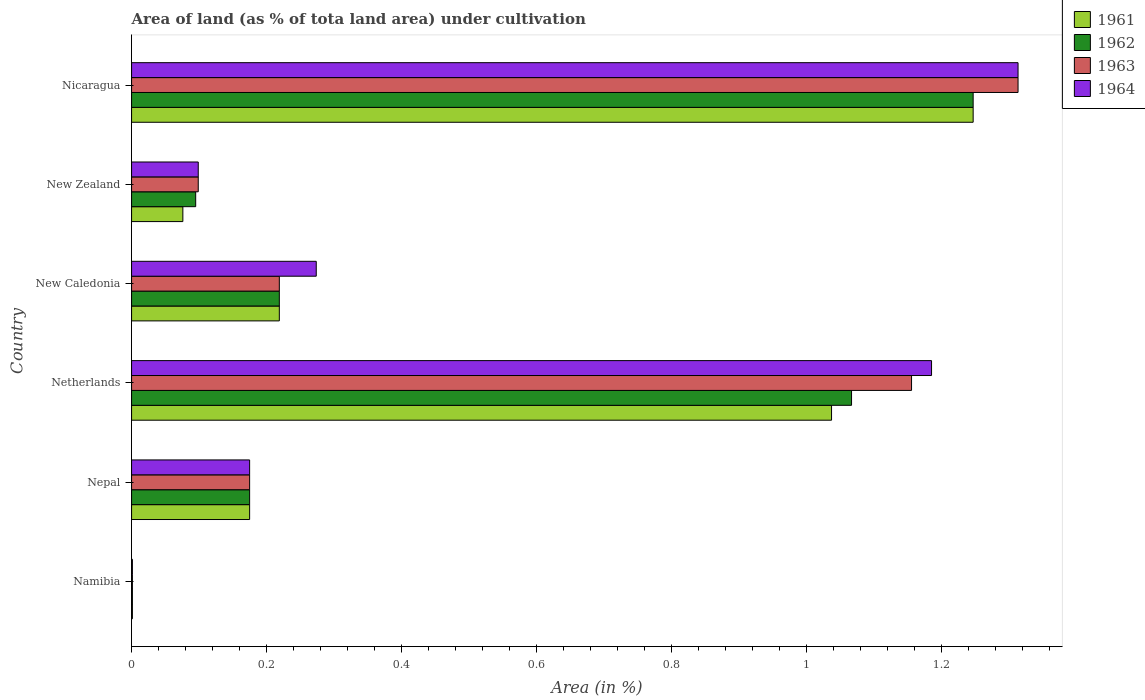How many different coloured bars are there?
Give a very brief answer. 4. Are the number of bars per tick equal to the number of legend labels?
Provide a succinct answer. Yes. Are the number of bars on each tick of the Y-axis equal?
Your answer should be compact. Yes. How many bars are there on the 6th tick from the top?
Offer a terse response. 4. What is the label of the 2nd group of bars from the top?
Offer a very short reply. New Zealand. What is the percentage of land under cultivation in 1961 in New Zealand?
Provide a short and direct response. 0.08. Across all countries, what is the maximum percentage of land under cultivation in 1962?
Provide a short and direct response. 1.25. Across all countries, what is the minimum percentage of land under cultivation in 1962?
Provide a succinct answer. 0. In which country was the percentage of land under cultivation in 1961 maximum?
Ensure brevity in your answer.  Nicaragua. In which country was the percentage of land under cultivation in 1961 minimum?
Your answer should be very brief. Namibia. What is the total percentage of land under cultivation in 1964 in the graph?
Ensure brevity in your answer.  3.05. What is the difference between the percentage of land under cultivation in 1964 in Nepal and that in New Zealand?
Provide a short and direct response. 0.08. What is the difference between the percentage of land under cultivation in 1963 in Nicaragua and the percentage of land under cultivation in 1961 in New Caledonia?
Your answer should be compact. 1.09. What is the average percentage of land under cultivation in 1961 per country?
Offer a very short reply. 0.46. What is the difference between the percentage of land under cultivation in 1961 and percentage of land under cultivation in 1963 in Nepal?
Keep it short and to the point. 0. In how many countries, is the percentage of land under cultivation in 1964 greater than 0.44 %?
Your answer should be compact. 2. What is the ratio of the percentage of land under cultivation in 1964 in Netherlands to that in New Zealand?
Provide a succinct answer. 12. What is the difference between the highest and the second highest percentage of land under cultivation in 1961?
Make the answer very short. 0.21. What is the difference between the highest and the lowest percentage of land under cultivation in 1963?
Make the answer very short. 1.31. In how many countries, is the percentage of land under cultivation in 1963 greater than the average percentage of land under cultivation in 1963 taken over all countries?
Provide a succinct answer. 2. Is the sum of the percentage of land under cultivation in 1963 in Nepal and New Caledonia greater than the maximum percentage of land under cultivation in 1961 across all countries?
Ensure brevity in your answer.  No. What does the 2nd bar from the top in Netherlands represents?
Give a very brief answer. 1963. What does the 4th bar from the bottom in Netherlands represents?
Provide a short and direct response. 1964. How many bars are there?
Provide a short and direct response. 24. Are all the bars in the graph horizontal?
Your answer should be very brief. Yes. Are the values on the major ticks of X-axis written in scientific E-notation?
Make the answer very short. No. What is the title of the graph?
Give a very brief answer. Area of land (as % of tota land area) under cultivation. Does "2012" appear as one of the legend labels in the graph?
Provide a short and direct response. No. What is the label or title of the X-axis?
Offer a very short reply. Area (in %). What is the Area (in %) of 1961 in Namibia?
Offer a very short reply. 0. What is the Area (in %) in 1962 in Namibia?
Offer a very short reply. 0. What is the Area (in %) in 1963 in Namibia?
Keep it short and to the point. 0. What is the Area (in %) of 1964 in Namibia?
Your response must be concise. 0. What is the Area (in %) of 1961 in Nepal?
Your answer should be very brief. 0.17. What is the Area (in %) of 1962 in Nepal?
Your response must be concise. 0.17. What is the Area (in %) in 1963 in Nepal?
Your answer should be compact. 0.17. What is the Area (in %) of 1964 in Nepal?
Ensure brevity in your answer.  0.17. What is the Area (in %) of 1961 in Netherlands?
Your answer should be compact. 1.04. What is the Area (in %) in 1962 in Netherlands?
Keep it short and to the point. 1.07. What is the Area (in %) in 1963 in Netherlands?
Provide a short and direct response. 1.16. What is the Area (in %) in 1964 in Netherlands?
Offer a terse response. 1.18. What is the Area (in %) of 1961 in New Caledonia?
Give a very brief answer. 0.22. What is the Area (in %) in 1962 in New Caledonia?
Provide a short and direct response. 0.22. What is the Area (in %) in 1963 in New Caledonia?
Offer a terse response. 0.22. What is the Area (in %) in 1964 in New Caledonia?
Give a very brief answer. 0.27. What is the Area (in %) in 1961 in New Zealand?
Provide a succinct answer. 0.08. What is the Area (in %) in 1962 in New Zealand?
Provide a succinct answer. 0.09. What is the Area (in %) in 1963 in New Zealand?
Keep it short and to the point. 0.1. What is the Area (in %) of 1964 in New Zealand?
Offer a very short reply. 0.1. What is the Area (in %) in 1961 in Nicaragua?
Keep it short and to the point. 1.25. What is the Area (in %) of 1962 in Nicaragua?
Ensure brevity in your answer.  1.25. What is the Area (in %) in 1963 in Nicaragua?
Offer a very short reply. 1.31. What is the Area (in %) of 1964 in Nicaragua?
Provide a short and direct response. 1.31. Across all countries, what is the maximum Area (in %) in 1961?
Offer a very short reply. 1.25. Across all countries, what is the maximum Area (in %) in 1962?
Offer a very short reply. 1.25. Across all countries, what is the maximum Area (in %) in 1963?
Offer a very short reply. 1.31. Across all countries, what is the maximum Area (in %) in 1964?
Offer a terse response. 1.31. Across all countries, what is the minimum Area (in %) of 1961?
Your response must be concise. 0. Across all countries, what is the minimum Area (in %) in 1962?
Provide a short and direct response. 0. Across all countries, what is the minimum Area (in %) of 1963?
Offer a very short reply. 0. Across all countries, what is the minimum Area (in %) of 1964?
Provide a short and direct response. 0. What is the total Area (in %) in 1961 in the graph?
Give a very brief answer. 2.75. What is the total Area (in %) in 1962 in the graph?
Offer a terse response. 2.8. What is the total Area (in %) of 1963 in the graph?
Give a very brief answer. 2.96. What is the total Area (in %) in 1964 in the graph?
Ensure brevity in your answer.  3.05. What is the difference between the Area (in %) in 1961 in Namibia and that in Nepal?
Give a very brief answer. -0.17. What is the difference between the Area (in %) of 1962 in Namibia and that in Nepal?
Your answer should be very brief. -0.17. What is the difference between the Area (in %) in 1963 in Namibia and that in Nepal?
Give a very brief answer. -0.17. What is the difference between the Area (in %) in 1964 in Namibia and that in Nepal?
Your response must be concise. -0.17. What is the difference between the Area (in %) in 1961 in Namibia and that in Netherlands?
Provide a short and direct response. -1.04. What is the difference between the Area (in %) in 1962 in Namibia and that in Netherlands?
Offer a terse response. -1.07. What is the difference between the Area (in %) of 1963 in Namibia and that in Netherlands?
Keep it short and to the point. -1.15. What is the difference between the Area (in %) in 1964 in Namibia and that in Netherlands?
Offer a terse response. -1.18. What is the difference between the Area (in %) of 1961 in Namibia and that in New Caledonia?
Your answer should be compact. -0.22. What is the difference between the Area (in %) in 1962 in Namibia and that in New Caledonia?
Provide a succinct answer. -0.22. What is the difference between the Area (in %) of 1963 in Namibia and that in New Caledonia?
Give a very brief answer. -0.22. What is the difference between the Area (in %) in 1964 in Namibia and that in New Caledonia?
Your answer should be compact. -0.27. What is the difference between the Area (in %) of 1961 in Namibia and that in New Zealand?
Ensure brevity in your answer.  -0.07. What is the difference between the Area (in %) of 1962 in Namibia and that in New Zealand?
Offer a very short reply. -0.09. What is the difference between the Area (in %) in 1963 in Namibia and that in New Zealand?
Make the answer very short. -0.1. What is the difference between the Area (in %) of 1964 in Namibia and that in New Zealand?
Give a very brief answer. -0.1. What is the difference between the Area (in %) of 1961 in Namibia and that in Nicaragua?
Provide a short and direct response. -1.25. What is the difference between the Area (in %) in 1962 in Namibia and that in Nicaragua?
Keep it short and to the point. -1.25. What is the difference between the Area (in %) in 1963 in Namibia and that in Nicaragua?
Offer a very short reply. -1.31. What is the difference between the Area (in %) of 1964 in Namibia and that in Nicaragua?
Your answer should be very brief. -1.31. What is the difference between the Area (in %) in 1961 in Nepal and that in Netherlands?
Make the answer very short. -0.86. What is the difference between the Area (in %) in 1962 in Nepal and that in Netherlands?
Offer a very short reply. -0.89. What is the difference between the Area (in %) of 1963 in Nepal and that in Netherlands?
Offer a terse response. -0.98. What is the difference between the Area (in %) of 1964 in Nepal and that in Netherlands?
Make the answer very short. -1.01. What is the difference between the Area (in %) of 1961 in Nepal and that in New Caledonia?
Make the answer very short. -0.04. What is the difference between the Area (in %) in 1962 in Nepal and that in New Caledonia?
Your response must be concise. -0.04. What is the difference between the Area (in %) of 1963 in Nepal and that in New Caledonia?
Ensure brevity in your answer.  -0.04. What is the difference between the Area (in %) in 1964 in Nepal and that in New Caledonia?
Offer a terse response. -0.1. What is the difference between the Area (in %) of 1961 in Nepal and that in New Zealand?
Your response must be concise. 0.1. What is the difference between the Area (in %) of 1962 in Nepal and that in New Zealand?
Keep it short and to the point. 0.08. What is the difference between the Area (in %) in 1963 in Nepal and that in New Zealand?
Provide a succinct answer. 0.08. What is the difference between the Area (in %) of 1964 in Nepal and that in New Zealand?
Provide a short and direct response. 0.08. What is the difference between the Area (in %) in 1961 in Nepal and that in Nicaragua?
Offer a terse response. -1.07. What is the difference between the Area (in %) in 1962 in Nepal and that in Nicaragua?
Keep it short and to the point. -1.07. What is the difference between the Area (in %) in 1963 in Nepal and that in Nicaragua?
Offer a terse response. -1.14. What is the difference between the Area (in %) in 1964 in Nepal and that in Nicaragua?
Offer a terse response. -1.14. What is the difference between the Area (in %) in 1961 in Netherlands and that in New Caledonia?
Provide a short and direct response. 0.82. What is the difference between the Area (in %) in 1962 in Netherlands and that in New Caledonia?
Ensure brevity in your answer.  0.85. What is the difference between the Area (in %) in 1963 in Netherlands and that in New Caledonia?
Keep it short and to the point. 0.94. What is the difference between the Area (in %) of 1964 in Netherlands and that in New Caledonia?
Offer a very short reply. 0.91. What is the difference between the Area (in %) of 1961 in Netherlands and that in New Zealand?
Provide a succinct answer. 0.96. What is the difference between the Area (in %) in 1962 in Netherlands and that in New Zealand?
Your response must be concise. 0.97. What is the difference between the Area (in %) in 1963 in Netherlands and that in New Zealand?
Ensure brevity in your answer.  1.06. What is the difference between the Area (in %) in 1964 in Netherlands and that in New Zealand?
Ensure brevity in your answer.  1.09. What is the difference between the Area (in %) of 1961 in Netherlands and that in Nicaragua?
Your answer should be very brief. -0.21. What is the difference between the Area (in %) in 1962 in Netherlands and that in Nicaragua?
Keep it short and to the point. -0.18. What is the difference between the Area (in %) of 1963 in Netherlands and that in Nicaragua?
Keep it short and to the point. -0.16. What is the difference between the Area (in %) of 1964 in Netherlands and that in Nicaragua?
Keep it short and to the point. -0.13. What is the difference between the Area (in %) in 1961 in New Caledonia and that in New Zealand?
Provide a short and direct response. 0.14. What is the difference between the Area (in %) of 1962 in New Caledonia and that in New Zealand?
Give a very brief answer. 0.12. What is the difference between the Area (in %) of 1963 in New Caledonia and that in New Zealand?
Offer a terse response. 0.12. What is the difference between the Area (in %) of 1964 in New Caledonia and that in New Zealand?
Make the answer very short. 0.17. What is the difference between the Area (in %) in 1961 in New Caledonia and that in Nicaragua?
Provide a short and direct response. -1.03. What is the difference between the Area (in %) of 1962 in New Caledonia and that in Nicaragua?
Provide a succinct answer. -1.03. What is the difference between the Area (in %) in 1963 in New Caledonia and that in Nicaragua?
Offer a very short reply. -1.09. What is the difference between the Area (in %) of 1964 in New Caledonia and that in Nicaragua?
Give a very brief answer. -1.04. What is the difference between the Area (in %) in 1961 in New Zealand and that in Nicaragua?
Your answer should be very brief. -1.17. What is the difference between the Area (in %) in 1962 in New Zealand and that in Nicaragua?
Provide a succinct answer. -1.15. What is the difference between the Area (in %) of 1963 in New Zealand and that in Nicaragua?
Offer a very short reply. -1.21. What is the difference between the Area (in %) of 1964 in New Zealand and that in Nicaragua?
Provide a succinct answer. -1.21. What is the difference between the Area (in %) of 1961 in Namibia and the Area (in %) of 1962 in Nepal?
Offer a terse response. -0.17. What is the difference between the Area (in %) of 1961 in Namibia and the Area (in %) of 1963 in Nepal?
Your answer should be very brief. -0.17. What is the difference between the Area (in %) in 1961 in Namibia and the Area (in %) in 1964 in Nepal?
Provide a succinct answer. -0.17. What is the difference between the Area (in %) in 1962 in Namibia and the Area (in %) in 1963 in Nepal?
Your response must be concise. -0.17. What is the difference between the Area (in %) in 1962 in Namibia and the Area (in %) in 1964 in Nepal?
Make the answer very short. -0.17. What is the difference between the Area (in %) in 1963 in Namibia and the Area (in %) in 1964 in Nepal?
Keep it short and to the point. -0.17. What is the difference between the Area (in %) in 1961 in Namibia and the Area (in %) in 1962 in Netherlands?
Provide a short and direct response. -1.07. What is the difference between the Area (in %) in 1961 in Namibia and the Area (in %) in 1963 in Netherlands?
Your response must be concise. -1.15. What is the difference between the Area (in %) in 1961 in Namibia and the Area (in %) in 1964 in Netherlands?
Your answer should be very brief. -1.18. What is the difference between the Area (in %) in 1962 in Namibia and the Area (in %) in 1963 in Netherlands?
Provide a succinct answer. -1.15. What is the difference between the Area (in %) in 1962 in Namibia and the Area (in %) in 1964 in Netherlands?
Provide a succinct answer. -1.18. What is the difference between the Area (in %) in 1963 in Namibia and the Area (in %) in 1964 in Netherlands?
Provide a succinct answer. -1.18. What is the difference between the Area (in %) of 1961 in Namibia and the Area (in %) of 1962 in New Caledonia?
Ensure brevity in your answer.  -0.22. What is the difference between the Area (in %) in 1961 in Namibia and the Area (in %) in 1963 in New Caledonia?
Offer a very short reply. -0.22. What is the difference between the Area (in %) in 1961 in Namibia and the Area (in %) in 1964 in New Caledonia?
Provide a short and direct response. -0.27. What is the difference between the Area (in %) of 1962 in Namibia and the Area (in %) of 1963 in New Caledonia?
Your answer should be very brief. -0.22. What is the difference between the Area (in %) of 1962 in Namibia and the Area (in %) of 1964 in New Caledonia?
Keep it short and to the point. -0.27. What is the difference between the Area (in %) in 1963 in Namibia and the Area (in %) in 1964 in New Caledonia?
Your answer should be very brief. -0.27. What is the difference between the Area (in %) in 1961 in Namibia and the Area (in %) in 1962 in New Zealand?
Offer a terse response. -0.09. What is the difference between the Area (in %) of 1961 in Namibia and the Area (in %) of 1963 in New Zealand?
Offer a terse response. -0.1. What is the difference between the Area (in %) in 1961 in Namibia and the Area (in %) in 1964 in New Zealand?
Provide a short and direct response. -0.1. What is the difference between the Area (in %) in 1962 in Namibia and the Area (in %) in 1963 in New Zealand?
Your answer should be compact. -0.1. What is the difference between the Area (in %) in 1962 in Namibia and the Area (in %) in 1964 in New Zealand?
Your answer should be compact. -0.1. What is the difference between the Area (in %) of 1963 in Namibia and the Area (in %) of 1964 in New Zealand?
Your answer should be compact. -0.1. What is the difference between the Area (in %) in 1961 in Namibia and the Area (in %) in 1962 in Nicaragua?
Your response must be concise. -1.25. What is the difference between the Area (in %) in 1961 in Namibia and the Area (in %) in 1963 in Nicaragua?
Ensure brevity in your answer.  -1.31. What is the difference between the Area (in %) of 1961 in Namibia and the Area (in %) of 1964 in Nicaragua?
Your answer should be very brief. -1.31. What is the difference between the Area (in %) in 1962 in Namibia and the Area (in %) in 1963 in Nicaragua?
Your answer should be very brief. -1.31. What is the difference between the Area (in %) of 1962 in Namibia and the Area (in %) of 1964 in Nicaragua?
Provide a short and direct response. -1.31. What is the difference between the Area (in %) in 1963 in Namibia and the Area (in %) in 1964 in Nicaragua?
Give a very brief answer. -1.31. What is the difference between the Area (in %) of 1961 in Nepal and the Area (in %) of 1962 in Netherlands?
Provide a short and direct response. -0.89. What is the difference between the Area (in %) in 1961 in Nepal and the Area (in %) in 1963 in Netherlands?
Offer a terse response. -0.98. What is the difference between the Area (in %) in 1961 in Nepal and the Area (in %) in 1964 in Netherlands?
Ensure brevity in your answer.  -1.01. What is the difference between the Area (in %) in 1962 in Nepal and the Area (in %) in 1963 in Netherlands?
Offer a very short reply. -0.98. What is the difference between the Area (in %) of 1962 in Nepal and the Area (in %) of 1964 in Netherlands?
Your answer should be compact. -1.01. What is the difference between the Area (in %) of 1963 in Nepal and the Area (in %) of 1964 in Netherlands?
Provide a succinct answer. -1.01. What is the difference between the Area (in %) in 1961 in Nepal and the Area (in %) in 1962 in New Caledonia?
Ensure brevity in your answer.  -0.04. What is the difference between the Area (in %) of 1961 in Nepal and the Area (in %) of 1963 in New Caledonia?
Offer a terse response. -0.04. What is the difference between the Area (in %) in 1961 in Nepal and the Area (in %) in 1964 in New Caledonia?
Give a very brief answer. -0.1. What is the difference between the Area (in %) in 1962 in Nepal and the Area (in %) in 1963 in New Caledonia?
Your answer should be very brief. -0.04. What is the difference between the Area (in %) of 1962 in Nepal and the Area (in %) of 1964 in New Caledonia?
Your response must be concise. -0.1. What is the difference between the Area (in %) of 1963 in Nepal and the Area (in %) of 1964 in New Caledonia?
Keep it short and to the point. -0.1. What is the difference between the Area (in %) in 1961 in Nepal and the Area (in %) in 1962 in New Zealand?
Your answer should be very brief. 0.08. What is the difference between the Area (in %) in 1961 in Nepal and the Area (in %) in 1963 in New Zealand?
Your answer should be very brief. 0.08. What is the difference between the Area (in %) of 1961 in Nepal and the Area (in %) of 1964 in New Zealand?
Offer a terse response. 0.08. What is the difference between the Area (in %) in 1962 in Nepal and the Area (in %) in 1963 in New Zealand?
Give a very brief answer. 0.08. What is the difference between the Area (in %) in 1962 in Nepal and the Area (in %) in 1964 in New Zealand?
Your response must be concise. 0.08. What is the difference between the Area (in %) of 1963 in Nepal and the Area (in %) of 1964 in New Zealand?
Your response must be concise. 0.08. What is the difference between the Area (in %) of 1961 in Nepal and the Area (in %) of 1962 in Nicaragua?
Your answer should be very brief. -1.07. What is the difference between the Area (in %) of 1961 in Nepal and the Area (in %) of 1963 in Nicaragua?
Ensure brevity in your answer.  -1.14. What is the difference between the Area (in %) in 1961 in Nepal and the Area (in %) in 1964 in Nicaragua?
Provide a short and direct response. -1.14. What is the difference between the Area (in %) of 1962 in Nepal and the Area (in %) of 1963 in Nicaragua?
Make the answer very short. -1.14. What is the difference between the Area (in %) in 1962 in Nepal and the Area (in %) in 1964 in Nicaragua?
Your answer should be very brief. -1.14. What is the difference between the Area (in %) in 1963 in Nepal and the Area (in %) in 1964 in Nicaragua?
Your answer should be very brief. -1.14. What is the difference between the Area (in %) in 1961 in Netherlands and the Area (in %) in 1962 in New Caledonia?
Offer a very short reply. 0.82. What is the difference between the Area (in %) in 1961 in Netherlands and the Area (in %) in 1963 in New Caledonia?
Offer a very short reply. 0.82. What is the difference between the Area (in %) in 1961 in Netherlands and the Area (in %) in 1964 in New Caledonia?
Make the answer very short. 0.76. What is the difference between the Area (in %) of 1962 in Netherlands and the Area (in %) of 1963 in New Caledonia?
Make the answer very short. 0.85. What is the difference between the Area (in %) of 1962 in Netherlands and the Area (in %) of 1964 in New Caledonia?
Offer a very short reply. 0.79. What is the difference between the Area (in %) of 1963 in Netherlands and the Area (in %) of 1964 in New Caledonia?
Offer a terse response. 0.88. What is the difference between the Area (in %) of 1961 in Netherlands and the Area (in %) of 1962 in New Zealand?
Offer a very short reply. 0.94. What is the difference between the Area (in %) in 1961 in Netherlands and the Area (in %) in 1963 in New Zealand?
Make the answer very short. 0.94. What is the difference between the Area (in %) in 1961 in Netherlands and the Area (in %) in 1964 in New Zealand?
Offer a terse response. 0.94. What is the difference between the Area (in %) in 1962 in Netherlands and the Area (in %) in 1963 in New Zealand?
Keep it short and to the point. 0.97. What is the difference between the Area (in %) of 1962 in Netherlands and the Area (in %) of 1964 in New Zealand?
Your answer should be very brief. 0.97. What is the difference between the Area (in %) of 1963 in Netherlands and the Area (in %) of 1964 in New Zealand?
Your answer should be very brief. 1.06. What is the difference between the Area (in %) of 1961 in Netherlands and the Area (in %) of 1962 in Nicaragua?
Ensure brevity in your answer.  -0.21. What is the difference between the Area (in %) in 1961 in Netherlands and the Area (in %) in 1963 in Nicaragua?
Keep it short and to the point. -0.28. What is the difference between the Area (in %) in 1961 in Netherlands and the Area (in %) in 1964 in Nicaragua?
Keep it short and to the point. -0.28. What is the difference between the Area (in %) of 1962 in Netherlands and the Area (in %) of 1963 in Nicaragua?
Provide a short and direct response. -0.25. What is the difference between the Area (in %) in 1962 in Netherlands and the Area (in %) in 1964 in Nicaragua?
Make the answer very short. -0.25. What is the difference between the Area (in %) of 1963 in Netherlands and the Area (in %) of 1964 in Nicaragua?
Your answer should be compact. -0.16. What is the difference between the Area (in %) of 1961 in New Caledonia and the Area (in %) of 1962 in New Zealand?
Make the answer very short. 0.12. What is the difference between the Area (in %) in 1961 in New Caledonia and the Area (in %) in 1963 in New Zealand?
Give a very brief answer. 0.12. What is the difference between the Area (in %) in 1961 in New Caledonia and the Area (in %) in 1964 in New Zealand?
Give a very brief answer. 0.12. What is the difference between the Area (in %) in 1962 in New Caledonia and the Area (in %) in 1963 in New Zealand?
Make the answer very short. 0.12. What is the difference between the Area (in %) in 1962 in New Caledonia and the Area (in %) in 1964 in New Zealand?
Your response must be concise. 0.12. What is the difference between the Area (in %) of 1963 in New Caledonia and the Area (in %) of 1964 in New Zealand?
Your response must be concise. 0.12. What is the difference between the Area (in %) in 1961 in New Caledonia and the Area (in %) in 1962 in Nicaragua?
Offer a very short reply. -1.03. What is the difference between the Area (in %) of 1961 in New Caledonia and the Area (in %) of 1963 in Nicaragua?
Keep it short and to the point. -1.09. What is the difference between the Area (in %) of 1961 in New Caledonia and the Area (in %) of 1964 in Nicaragua?
Make the answer very short. -1.09. What is the difference between the Area (in %) of 1962 in New Caledonia and the Area (in %) of 1963 in Nicaragua?
Offer a very short reply. -1.09. What is the difference between the Area (in %) of 1962 in New Caledonia and the Area (in %) of 1964 in Nicaragua?
Your response must be concise. -1.09. What is the difference between the Area (in %) in 1963 in New Caledonia and the Area (in %) in 1964 in Nicaragua?
Your answer should be very brief. -1.09. What is the difference between the Area (in %) in 1961 in New Zealand and the Area (in %) in 1962 in Nicaragua?
Your answer should be compact. -1.17. What is the difference between the Area (in %) in 1961 in New Zealand and the Area (in %) in 1963 in Nicaragua?
Your answer should be very brief. -1.24. What is the difference between the Area (in %) in 1961 in New Zealand and the Area (in %) in 1964 in Nicaragua?
Give a very brief answer. -1.24. What is the difference between the Area (in %) of 1962 in New Zealand and the Area (in %) of 1963 in Nicaragua?
Make the answer very short. -1.22. What is the difference between the Area (in %) in 1962 in New Zealand and the Area (in %) in 1964 in Nicaragua?
Ensure brevity in your answer.  -1.22. What is the difference between the Area (in %) in 1963 in New Zealand and the Area (in %) in 1964 in Nicaragua?
Make the answer very short. -1.21. What is the average Area (in %) in 1961 per country?
Offer a very short reply. 0.46. What is the average Area (in %) of 1962 per country?
Your response must be concise. 0.47. What is the average Area (in %) of 1963 per country?
Make the answer very short. 0.49. What is the average Area (in %) in 1964 per country?
Ensure brevity in your answer.  0.51. What is the difference between the Area (in %) of 1961 and Area (in %) of 1963 in Namibia?
Your response must be concise. 0. What is the difference between the Area (in %) in 1963 and Area (in %) in 1964 in Namibia?
Provide a short and direct response. 0. What is the difference between the Area (in %) of 1961 and Area (in %) of 1963 in Nepal?
Offer a very short reply. 0. What is the difference between the Area (in %) of 1961 and Area (in %) of 1964 in Nepal?
Your answer should be very brief. 0. What is the difference between the Area (in %) of 1962 and Area (in %) of 1963 in Nepal?
Your response must be concise. 0. What is the difference between the Area (in %) of 1962 and Area (in %) of 1964 in Nepal?
Provide a succinct answer. 0. What is the difference between the Area (in %) of 1961 and Area (in %) of 1962 in Netherlands?
Provide a succinct answer. -0.03. What is the difference between the Area (in %) in 1961 and Area (in %) in 1963 in Netherlands?
Offer a terse response. -0.12. What is the difference between the Area (in %) of 1961 and Area (in %) of 1964 in Netherlands?
Your answer should be compact. -0.15. What is the difference between the Area (in %) in 1962 and Area (in %) in 1963 in Netherlands?
Make the answer very short. -0.09. What is the difference between the Area (in %) of 1962 and Area (in %) of 1964 in Netherlands?
Your answer should be compact. -0.12. What is the difference between the Area (in %) in 1963 and Area (in %) in 1964 in Netherlands?
Give a very brief answer. -0.03. What is the difference between the Area (in %) in 1961 and Area (in %) in 1962 in New Caledonia?
Your answer should be compact. 0. What is the difference between the Area (in %) in 1961 and Area (in %) in 1964 in New Caledonia?
Offer a very short reply. -0.05. What is the difference between the Area (in %) of 1962 and Area (in %) of 1963 in New Caledonia?
Provide a short and direct response. 0. What is the difference between the Area (in %) in 1962 and Area (in %) in 1964 in New Caledonia?
Make the answer very short. -0.05. What is the difference between the Area (in %) of 1963 and Area (in %) of 1964 in New Caledonia?
Offer a very short reply. -0.05. What is the difference between the Area (in %) of 1961 and Area (in %) of 1962 in New Zealand?
Offer a very short reply. -0.02. What is the difference between the Area (in %) of 1961 and Area (in %) of 1963 in New Zealand?
Provide a succinct answer. -0.02. What is the difference between the Area (in %) of 1961 and Area (in %) of 1964 in New Zealand?
Offer a terse response. -0.02. What is the difference between the Area (in %) in 1962 and Area (in %) in 1963 in New Zealand?
Provide a short and direct response. -0. What is the difference between the Area (in %) of 1962 and Area (in %) of 1964 in New Zealand?
Your answer should be very brief. -0. What is the difference between the Area (in %) in 1961 and Area (in %) in 1963 in Nicaragua?
Give a very brief answer. -0.07. What is the difference between the Area (in %) of 1961 and Area (in %) of 1964 in Nicaragua?
Ensure brevity in your answer.  -0.07. What is the difference between the Area (in %) of 1962 and Area (in %) of 1963 in Nicaragua?
Your answer should be very brief. -0.07. What is the difference between the Area (in %) in 1962 and Area (in %) in 1964 in Nicaragua?
Keep it short and to the point. -0.07. What is the difference between the Area (in %) in 1963 and Area (in %) in 1964 in Nicaragua?
Ensure brevity in your answer.  0. What is the ratio of the Area (in %) of 1961 in Namibia to that in Nepal?
Your response must be concise. 0.01. What is the ratio of the Area (in %) of 1962 in Namibia to that in Nepal?
Your answer should be very brief. 0.01. What is the ratio of the Area (in %) in 1963 in Namibia to that in Nepal?
Keep it short and to the point. 0.01. What is the ratio of the Area (in %) of 1964 in Namibia to that in Nepal?
Provide a succinct answer. 0.01. What is the ratio of the Area (in %) of 1961 in Namibia to that in Netherlands?
Make the answer very short. 0. What is the ratio of the Area (in %) in 1962 in Namibia to that in Netherlands?
Make the answer very short. 0. What is the ratio of the Area (in %) in 1963 in Namibia to that in Netherlands?
Give a very brief answer. 0. What is the ratio of the Area (in %) of 1961 in Namibia to that in New Caledonia?
Ensure brevity in your answer.  0.01. What is the ratio of the Area (in %) of 1962 in Namibia to that in New Caledonia?
Give a very brief answer. 0.01. What is the ratio of the Area (in %) in 1963 in Namibia to that in New Caledonia?
Provide a short and direct response. 0.01. What is the ratio of the Area (in %) of 1964 in Namibia to that in New Caledonia?
Give a very brief answer. 0. What is the ratio of the Area (in %) of 1961 in Namibia to that in New Zealand?
Give a very brief answer. 0.02. What is the ratio of the Area (in %) in 1962 in Namibia to that in New Zealand?
Offer a terse response. 0.01. What is the ratio of the Area (in %) in 1963 in Namibia to that in New Zealand?
Provide a succinct answer. 0.01. What is the ratio of the Area (in %) in 1964 in Namibia to that in New Zealand?
Your answer should be compact. 0.01. What is the ratio of the Area (in %) of 1963 in Namibia to that in Nicaragua?
Your answer should be compact. 0. What is the ratio of the Area (in %) of 1964 in Namibia to that in Nicaragua?
Provide a short and direct response. 0. What is the ratio of the Area (in %) in 1961 in Nepal to that in Netherlands?
Give a very brief answer. 0.17. What is the ratio of the Area (in %) of 1962 in Nepal to that in Netherlands?
Your answer should be compact. 0.16. What is the ratio of the Area (in %) in 1963 in Nepal to that in Netherlands?
Offer a very short reply. 0.15. What is the ratio of the Area (in %) in 1964 in Nepal to that in Netherlands?
Give a very brief answer. 0.15. What is the ratio of the Area (in %) in 1961 in Nepal to that in New Caledonia?
Give a very brief answer. 0.8. What is the ratio of the Area (in %) of 1962 in Nepal to that in New Caledonia?
Give a very brief answer. 0.8. What is the ratio of the Area (in %) in 1963 in Nepal to that in New Caledonia?
Give a very brief answer. 0.8. What is the ratio of the Area (in %) in 1964 in Nepal to that in New Caledonia?
Your response must be concise. 0.64. What is the ratio of the Area (in %) of 1961 in Nepal to that in New Zealand?
Offer a terse response. 2.3. What is the ratio of the Area (in %) of 1962 in Nepal to that in New Zealand?
Keep it short and to the point. 1.84. What is the ratio of the Area (in %) in 1963 in Nepal to that in New Zealand?
Give a very brief answer. 1.77. What is the ratio of the Area (in %) of 1964 in Nepal to that in New Zealand?
Your answer should be compact. 1.77. What is the ratio of the Area (in %) of 1961 in Nepal to that in Nicaragua?
Give a very brief answer. 0.14. What is the ratio of the Area (in %) in 1962 in Nepal to that in Nicaragua?
Ensure brevity in your answer.  0.14. What is the ratio of the Area (in %) in 1963 in Nepal to that in Nicaragua?
Give a very brief answer. 0.13. What is the ratio of the Area (in %) in 1964 in Nepal to that in Nicaragua?
Offer a very short reply. 0.13. What is the ratio of the Area (in %) in 1961 in Netherlands to that in New Caledonia?
Make the answer very short. 4.74. What is the ratio of the Area (in %) of 1962 in Netherlands to that in New Caledonia?
Your answer should be very brief. 4.87. What is the ratio of the Area (in %) in 1963 in Netherlands to that in New Caledonia?
Your answer should be compact. 5.28. What is the ratio of the Area (in %) in 1964 in Netherlands to that in New Caledonia?
Your answer should be very brief. 4.33. What is the ratio of the Area (in %) in 1961 in Netherlands to that in New Zealand?
Your answer should be compact. 13.65. What is the ratio of the Area (in %) of 1962 in Netherlands to that in New Zealand?
Your response must be concise. 11.23. What is the ratio of the Area (in %) of 1963 in Netherlands to that in New Zealand?
Provide a succinct answer. 11.7. What is the ratio of the Area (in %) in 1964 in Netherlands to that in New Zealand?
Your answer should be compact. 12. What is the ratio of the Area (in %) in 1961 in Netherlands to that in Nicaragua?
Ensure brevity in your answer.  0.83. What is the ratio of the Area (in %) of 1962 in Netherlands to that in Nicaragua?
Keep it short and to the point. 0.86. What is the ratio of the Area (in %) of 1963 in Netherlands to that in Nicaragua?
Your answer should be very brief. 0.88. What is the ratio of the Area (in %) of 1964 in Netherlands to that in Nicaragua?
Offer a terse response. 0.9. What is the ratio of the Area (in %) of 1961 in New Caledonia to that in New Zealand?
Make the answer very short. 2.88. What is the ratio of the Area (in %) in 1962 in New Caledonia to that in New Zealand?
Offer a terse response. 2.3. What is the ratio of the Area (in %) in 1963 in New Caledonia to that in New Zealand?
Ensure brevity in your answer.  2.22. What is the ratio of the Area (in %) in 1964 in New Caledonia to that in New Zealand?
Your response must be concise. 2.77. What is the ratio of the Area (in %) of 1961 in New Caledonia to that in Nicaragua?
Your answer should be compact. 0.18. What is the ratio of the Area (in %) of 1962 in New Caledonia to that in Nicaragua?
Offer a terse response. 0.18. What is the ratio of the Area (in %) in 1964 in New Caledonia to that in Nicaragua?
Ensure brevity in your answer.  0.21. What is the ratio of the Area (in %) in 1961 in New Zealand to that in Nicaragua?
Make the answer very short. 0.06. What is the ratio of the Area (in %) of 1962 in New Zealand to that in Nicaragua?
Ensure brevity in your answer.  0.08. What is the ratio of the Area (in %) in 1963 in New Zealand to that in Nicaragua?
Make the answer very short. 0.08. What is the ratio of the Area (in %) of 1964 in New Zealand to that in Nicaragua?
Offer a terse response. 0.08. What is the difference between the highest and the second highest Area (in %) in 1961?
Give a very brief answer. 0.21. What is the difference between the highest and the second highest Area (in %) in 1962?
Your response must be concise. 0.18. What is the difference between the highest and the second highest Area (in %) of 1963?
Give a very brief answer. 0.16. What is the difference between the highest and the second highest Area (in %) of 1964?
Make the answer very short. 0.13. What is the difference between the highest and the lowest Area (in %) in 1961?
Provide a succinct answer. 1.25. What is the difference between the highest and the lowest Area (in %) of 1962?
Provide a short and direct response. 1.25. What is the difference between the highest and the lowest Area (in %) of 1963?
Your response must be concise. 1.31. What is the difference between the highest and the lowest Area (in %) in 1964?
Offer a terse response. 1.31. 